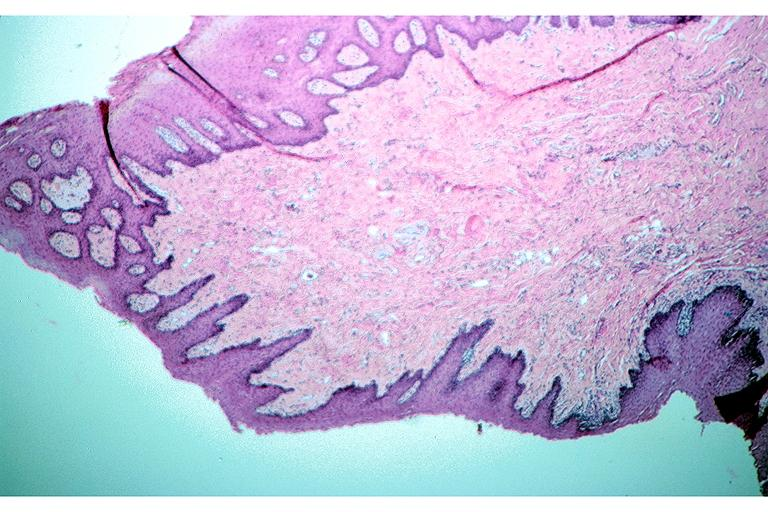what is present?
Answer the question using a single word or phrase. Oral 